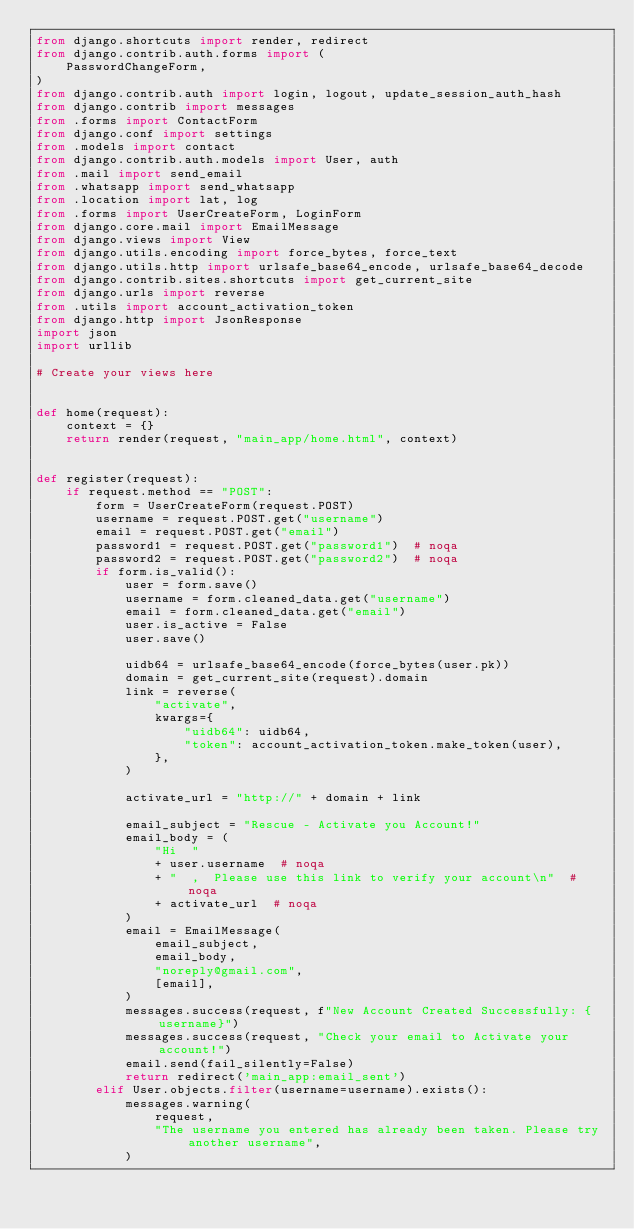<code> <loc_0><loc_0><loc_500><loc_500><_Python_>from django.shortcuts import render, redirect
from django.contrib.auth.forms import (
    PasswordChangeForm,
)
from django.contrib.auth import login, logout, update_session_auth_hash
from django.contrib import messages
from .forms import ContactForm
from django.conf import settings
from .models import contact
from django.contrib.auth.models import User, auth
from .mail import send_email
from .whatsapp import send_whatsapp
from .location import lat, log
from .forms import UserCreateForm, LoginForm
from django.core.mail import EmailMessage
from django.views import View
from django.utils.encoding import force_bytes, force_text
from django.utils.http import urlsafe_base64_encode, urlsafe_base64_decode
from django.contrib.sites.shortcuts import get_current_site
from django.urls import reverse
from .utils import account_activation_token
from django.http import JsonResponse
import json
import urllib

# Create your views here


def home(request):
    context = {}
    return render(request, "main_app/home.html", context)


def register(request):
    if request.method == "POST":
        form = UserCreateForm(request.POST)
        username = request.POST.get("username")
        email = request.POST.get("email")
        password1 = request.POST.get("password1")  # noqa
        password2 = request.POST.get("password2")  # noqa
        if form.is_valid():
            user = form.save()
            username = form.cleaned_data.get("username")
            email = form.cleaned_data.get("email")
            user.is_active = False
            user.save()

            uidb64 = urlsafe_base64_encode(force_bytes(user.pk))
            domain = get_current_site(request).domain
            link = reverse(
                "activate",
                kwargs={
                    "uidb64": uidb64,
                    "token": account_activation_token.make_token(user),
                },
            )

            activate_url = "http://" + domain + link

            email_subject = "Rescue - Activate you Account!"
            email_body = (
                "Hi  "
                + user.username  # noqa
                + "  ,  Please use this link to verify your account\n"  # noqa
                + activate_url  # noqa
            )
            email = EmailMessage(
                email_subject,
                email_body,
                "noreply@gmail.com",
                [email],
            )
            messages.success(request, f"New Account Created Successfully: {username}")
            messages.success(request, "Check your email to Activate your account!")
            email.send(fail_silently=False)
            return redirect('main_app:email_sent')
        elif User.objects.filter(username=username).exists():
            messages.warning(
                request,
                "The username you entered has already been taken. Please try another username",
            )</code> 